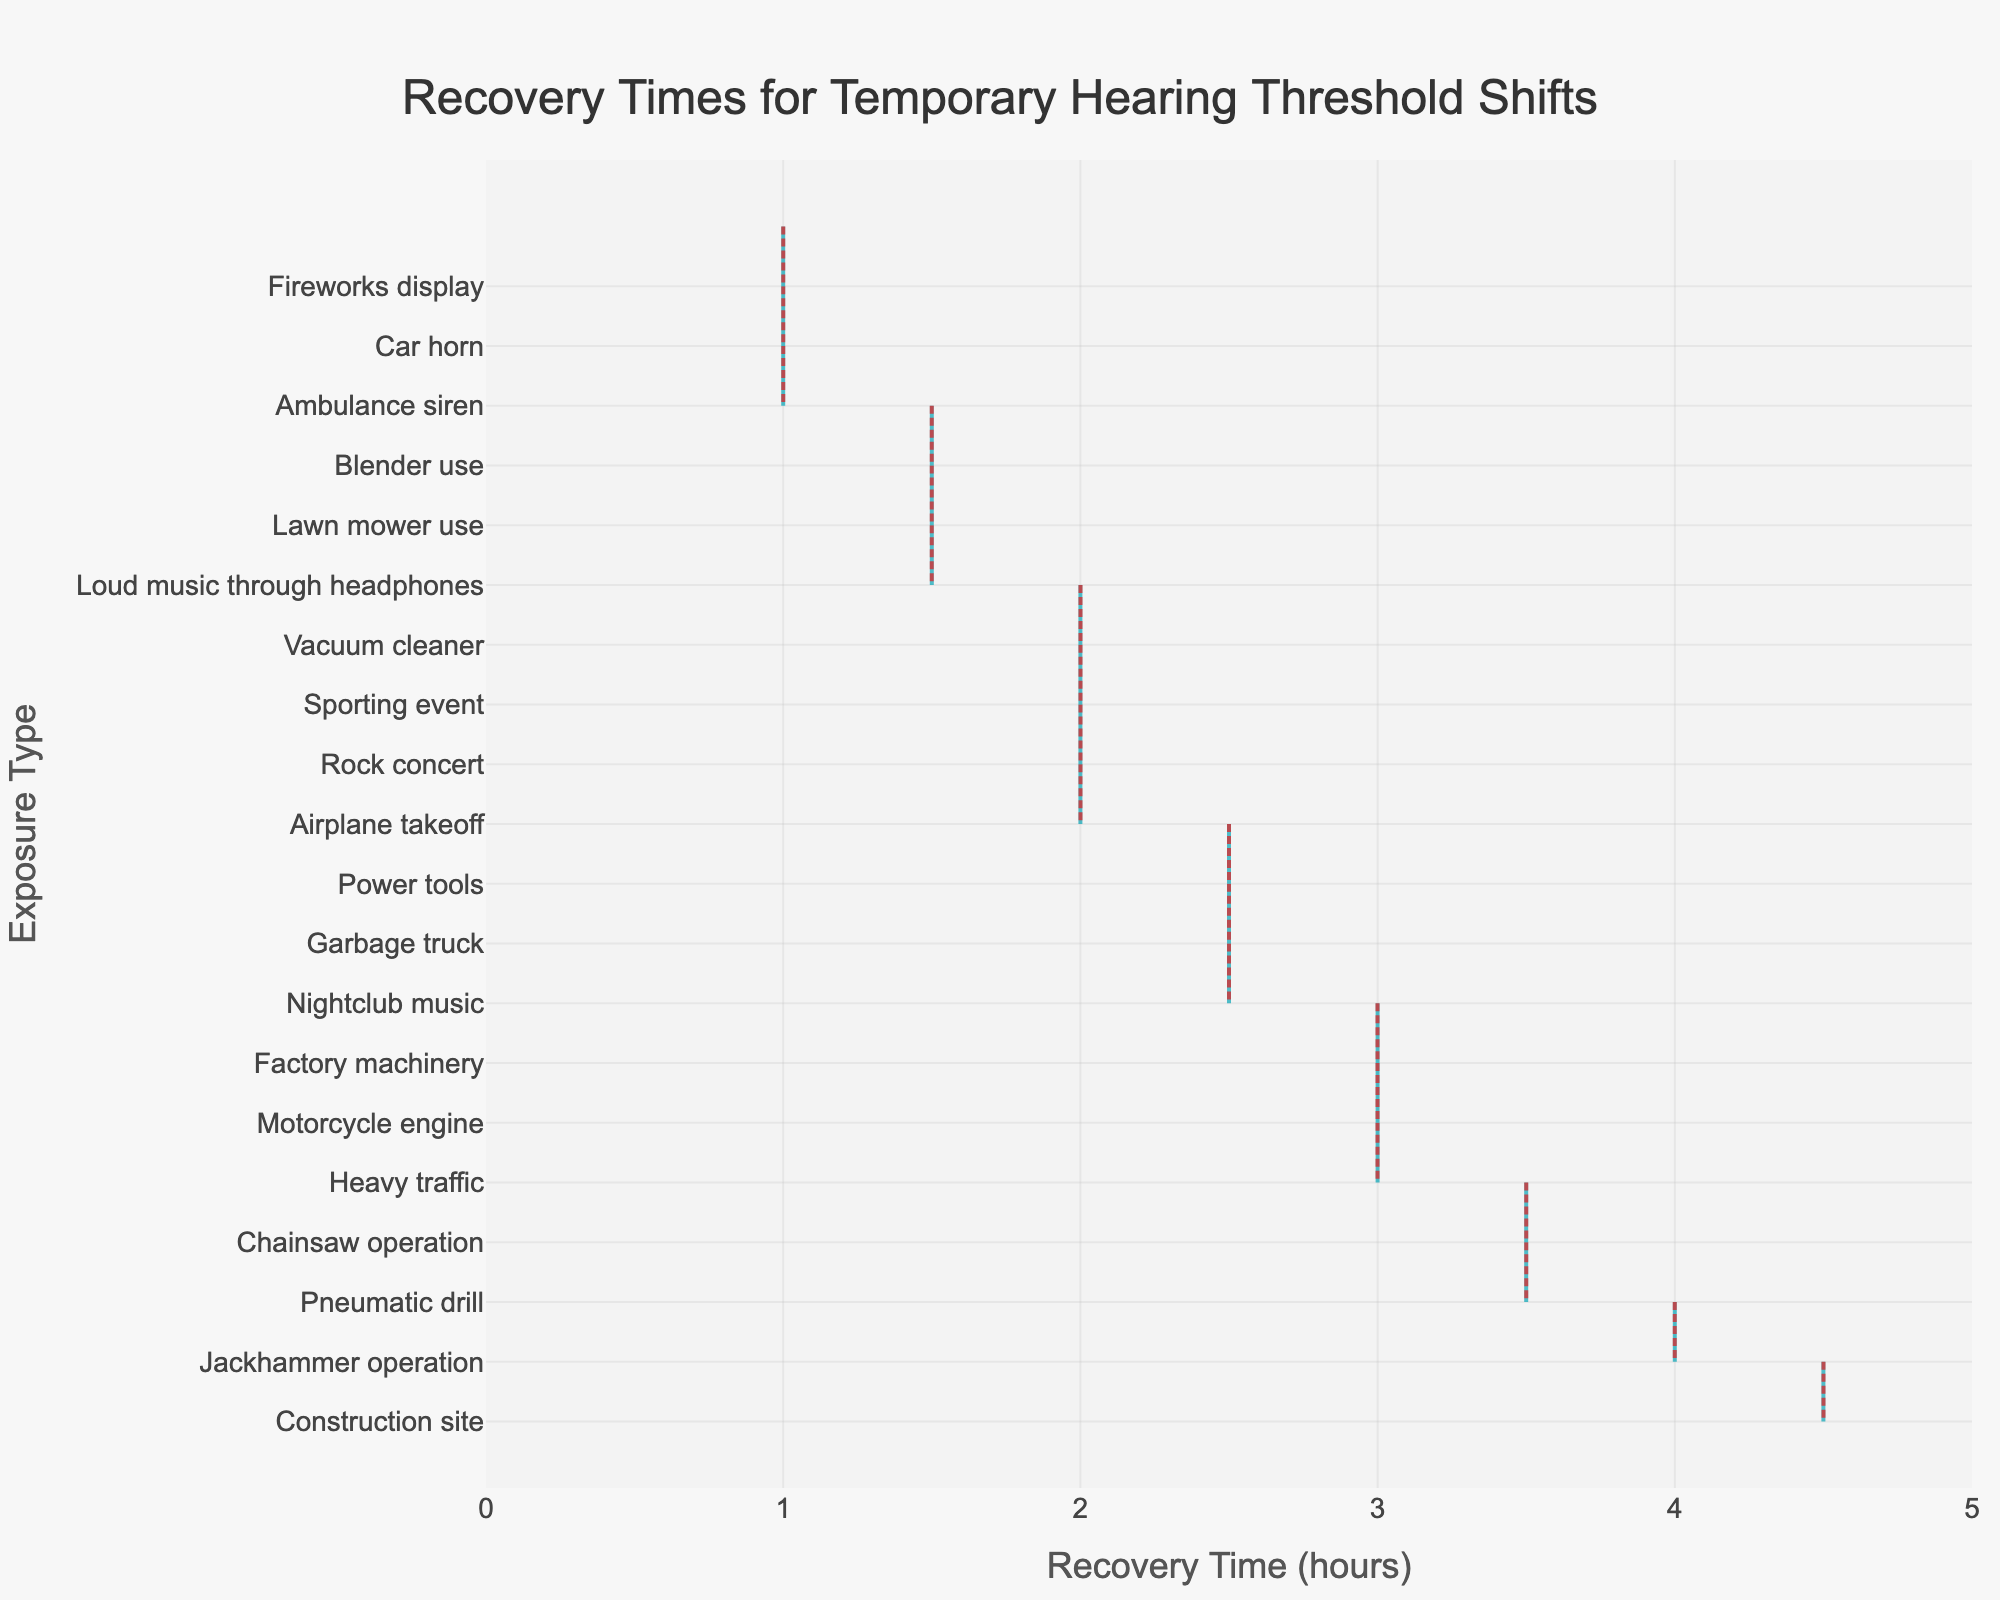What's the title of the plot? The title is located at the top center of the figure and is usually the most prominent and largest text. In this plot, the title reads "Recovery Times for Temporary Hearing Threshold Shifts".
Answer: Recovery Times for Temporary Hearing Threshold Shifts What does the x-axis represent? The x-axis is typically labeled directly below the axis line itself. In this case, the label is "Recovery Time (hours)", indicating that the x-axis represents the recovery time in hours.
Answer: Recovery Time (hours) Which exposure type has the longest recovery time? By observing the plot, we can see which distribution extends furthest along the x-axis. In this figure, "Construction site" has the longest visible span, reaching up to 4.5 hours.
Answer: Construction site How does the recovery time for "Rock concert" compare to "Fireworks display"? To compare, find the positions of "Rock concert" and "Fireworks display" along the x-axis. The recovery time for "Rock concert" is at 2 hours, while "Fireworks display" is at 1 hour.
Answer: Rock concert has a longer recovery time than Fireworks display Which exposure types have a recovery time of 2.5 hours? Look along the x-axis for the value 2.5 hours and note the exposure types listed at that point. These are "Nightclub music," "Power tools," and "Garbage truck."
Answer: Nightclub music, Power tools, Garbage truck What is the average recovery time for "Motorcycle engine"? Read the position of the "Motorcycle engine" distribution along the x-axis to find the mean. The figure shows it is positioned at 3 hours.
Answer: 3 hours Which exposure type has a recovery time closest to 1.5 hours but slightly higher? Identify the distributions that are around 1.5 hours and determine which one is slightly higher. "Blender use" is at 1.5 hours, but "Nightclub music" is slightly higher at 2.5 hours among those close values.
Answer: Nightclub music How does the width of the violin plot change the information interpretation? Wider sections of a violin plot indicate a higher density of data points in that range, while narrower sections show less density. This visualization helps to understand the distribution and variability of recovery times for each exposure type. For example, if "Rock concert" has a wider section around 2 hours, it indicates more occurrences of this recovery time.
Answer: Shows density of data points Are the mean recovery times highlighted in the plot? Violin plots often show a mean line to help highlight the average of the distribution. In this plot, the mean is shown as a visible line across the distribution which is distinctively indicated by a difference in color.
Answer: Yes 